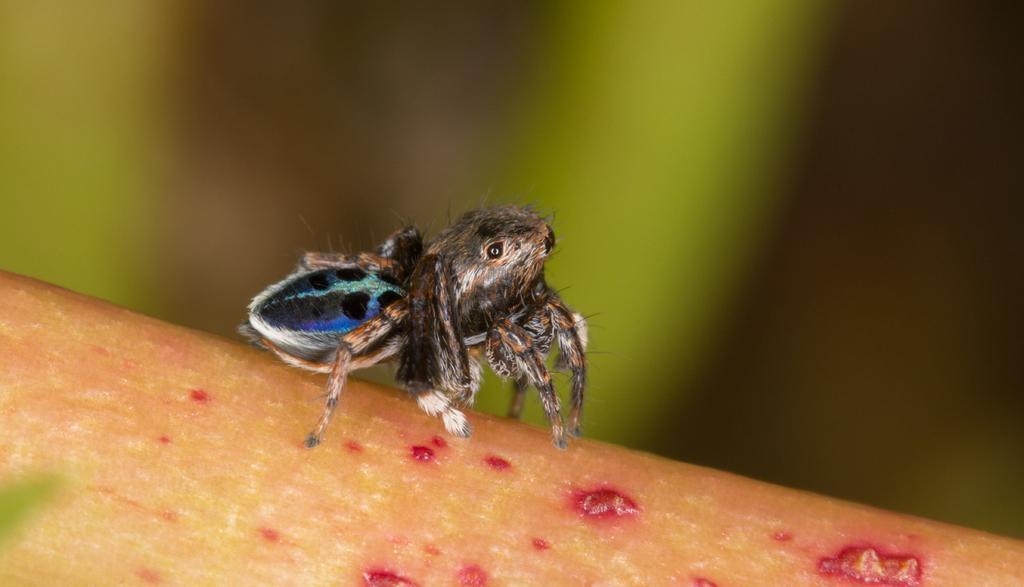Could you give a brief overview of what you see in this image? This is some kind of spider and it is biting on some object and the background is totally blur. 